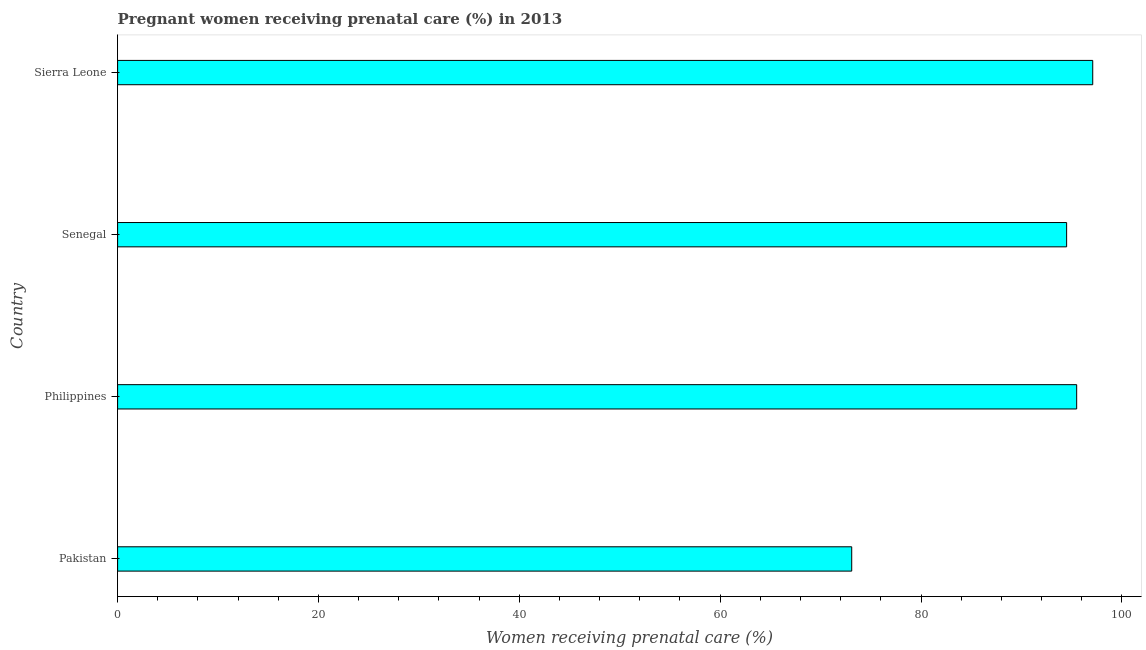Does the graph contain any zero values?
Keep it short and to the point. No. Does the graph contain grids?
Make the answer very short. No. What is the title of the graph?
Offer a very short reply. Pregnant women receiving prenatal care (%) in 2013. What is the label or title of the X-axis?
Provide a short and direct response. Women receiving prenatal care (%). What is the percentage of pregnant women receiving prenatal care in Sierra Leone?
Offer a very short reply. 97.1. Across all countries, what is the maximum percentage of pregnant women receiving prenatal care?
Your response must be concise. 97.1. Across all countries, what is the minimum percentage of pregnant women receiving prenatal care?
Your answer should be very brief. 73.1. In which country was the percentage of pregnant women receiving prenatal care maximum?
Offer a terse response. Sierra Leone. What is the sum of the percentage of pregnant women receiving prenatal care?
Give a very brief answer. 360.2. What is the average percentage of pregnant women receiving prenatal care per country?
Give a very brief answer. 90.05. What is the ratio of the percentage of pregnant women receiving prenatal care in Pakistan to that in Philippines?
Your response must be concise. 0.77. Is the difference between the percentage of pregnant women receiving prenatal care in Pakistan and Sierra Leone greater than the difference between any two countries?
Make the answer very short. Yes. What is the difference between the highest and the second highest percentage of pregnant women receiving prenatal care?
Your answer should be very brief. 1.6. Is the sum of the percentage of pregnant women receiving prenatal care in Philippines and Senegal greater than the maximum percentage of pregnant women receiving prenatal care across all countries?
Keep it short and to the point. Yes. What is the difference between the highest and the lowest percentage of pregnant women receiving prenatal care?
Keep it short and to the point. 24. In how many countries, is the percentage of pregnant women receiving prenatal care greater than the average percentage of pregnant women receiving prenatal care taken over all countries?
Make the answer very short. 3. How many bars are there?
Provide a succinct answer. 4. Are the values on the major ticks of X-axis written in scientific E-notation?
Ensure brevity in your answer.  No. What is the Women receiving prenatal care (%) in Pakistan?
Offer a very short reply. 73.1. What is the Women receiving prenatal care (%) in Philippines?
Your response must be concise. 95.5. What is the Women receiving prenatal care (%) in Senegal?
Offer a terse response. 94.5. What is the Women receiving prenatal care (%) in Sierra Leone?
Make the answer very short. 97.1. What is the difference between the Women receiving prenatal care (%) in Pakistan and Philippines?
Ensure brevity in your answer.  -22.4. What is the difference between the Women receiving prenatal care (%) in Pakistan and Senegal?
Give a very brief answer. -21.4. What is the difference between the Women receiving prenatal care (%) in Pakistan and Sierra Leone?
Your response must be concise. -24. What is the difference between the Women receiving prenatal care (%) in Philippines and Sierra Leone?
Give a very brief answer. -1.6. What is the difference between the Women receiving prenatal care (%) in Senegal and Sierra Leone?
Offer a very short reply. -2.6. What is the ratio of the Women receiving prenatal care (%) in Pakistan to that in Philippines?
Provide a short and direct response. 0.77. What is the ratio of the Women receiving prenatal care (%) in Pakistan to that in Senegal?
Offer a very short reply. 0.77. What is the ratio of the Women receiving prenatal care (%) in Pakistan to that in Sierra Leone?
Your answer should be compact. 0.75. What is the ratio of the Women receiving prenatal care (%) in Philippines to that in Senegal?
Your answer should be compact. 1.01. What is the ratio of the Women receiving prenatal care (%) in Senegal to that in Sierra Leone?
Your response must be concise. 0.97. 